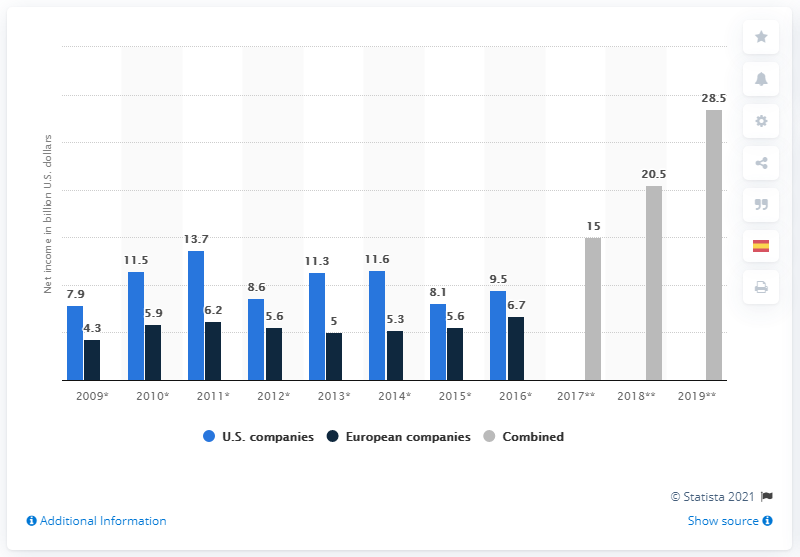List a handful of essential elements in this visual. The total net income of European companies from 2009 to 2010 was 10.2 billion euros. The combined net income in 2018 was approximately 20.5. 